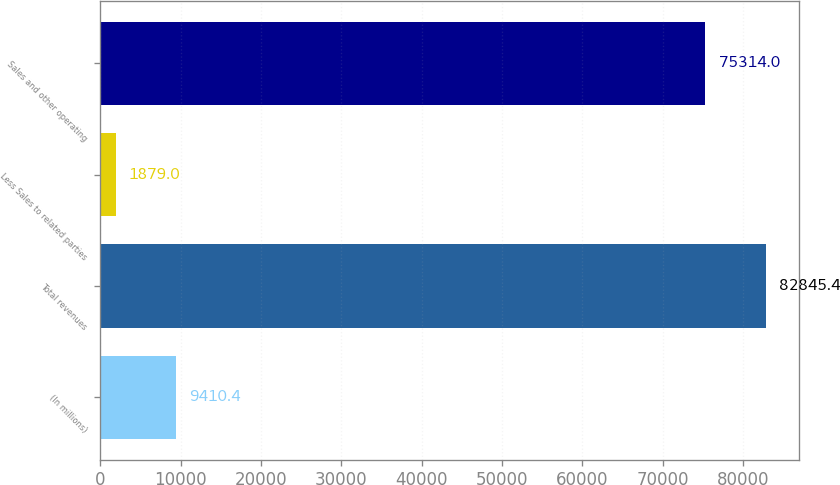Convert chart to OTSL. <chart><loc_0><loc_0><loc_500><loc_500><bar_chart><fcel>(In millions)<fcel>Total revenues<fcel>Less Sales to related parties<fcel>Sales and other operating<nl><fcel>9410.4<fcel>82845.4<fcel>1879<fcel>75314<nl></chart> 